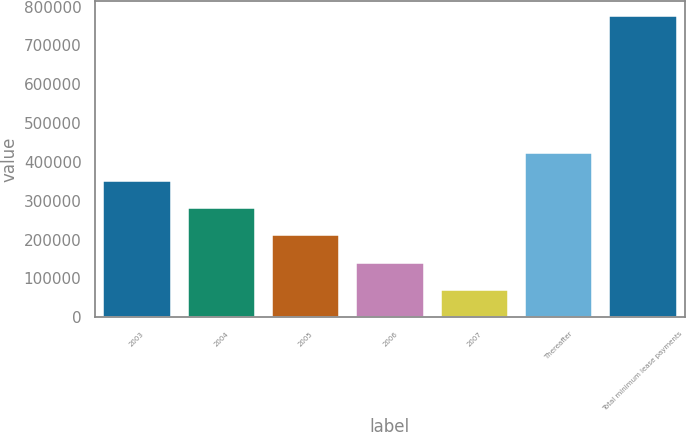Convert chart to OTSL. <chart><loc_0><loc_0><loc_500><loc_500><bar_chart><fcel>2003<fcel>2004<fcel>2005<fcel>2006<fcel>2007<fcel>Thereafter<fcel>Total minimum lease payments<nl><fcel>351939<fcel>281418<fcel>210898<fcel>140377<fcel>69857<fcel>422459<fcel>775061<nl></chart> 